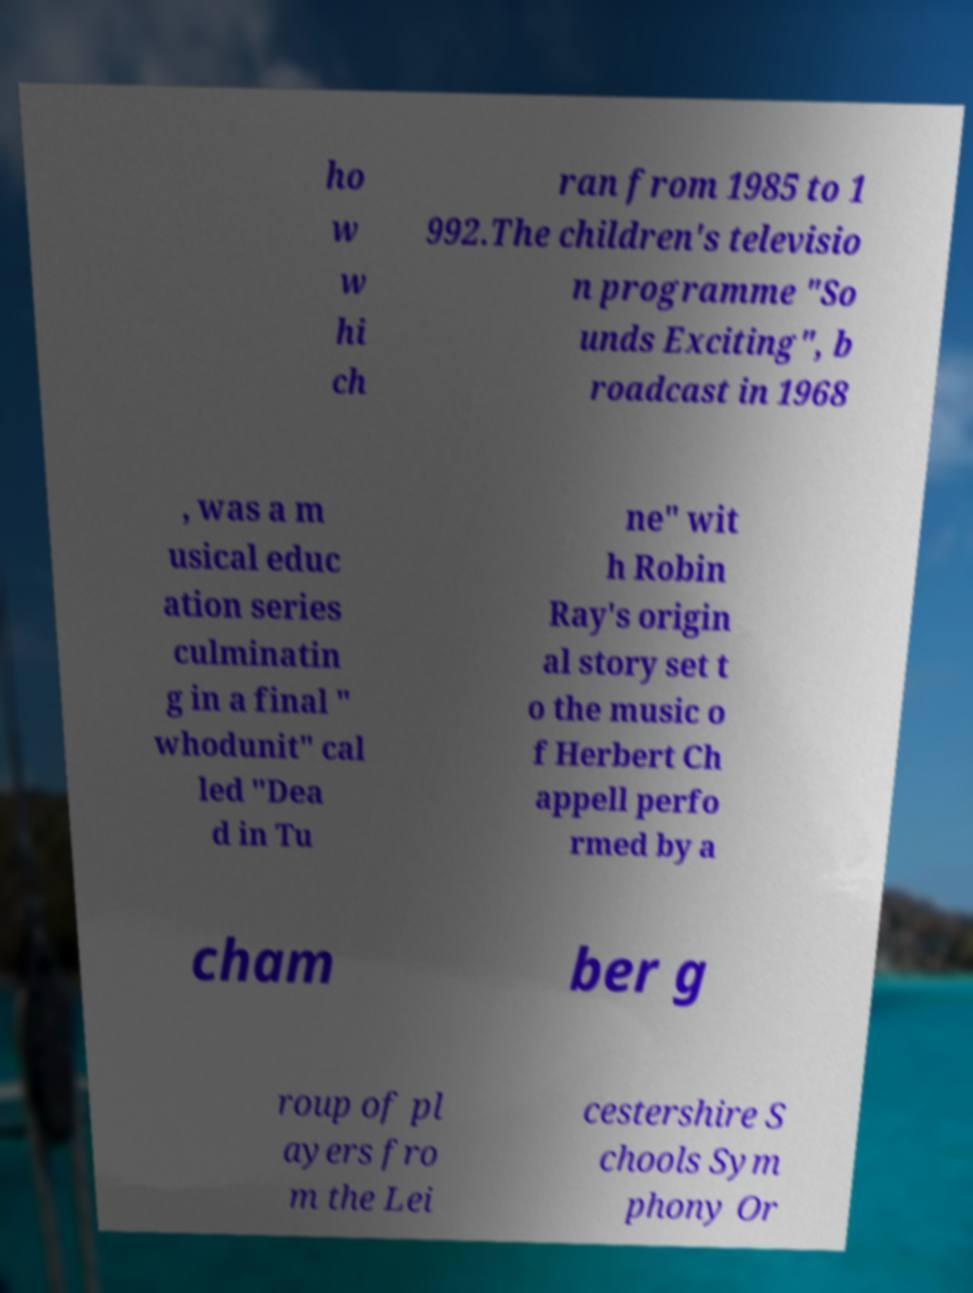Can you read and provide the text displayed in the image?This photo seems to have some interesting text. Can you extract and type it out for me? ho w w hi ch ran from 1985 to 1 992.The children's televisio n programme "So unds Exciting", b roadcast in 1968 , was a m usical educ ation series culminatin g in a final " whodunit" cal led "Dea d in Tu ne" wit h Robin Ray's origin al story set t o the music o f Herbert Ch appell perfo rmed by a cham ber g roup of pl ayers fro m the Lei cestershire S chools Sym phony Or 